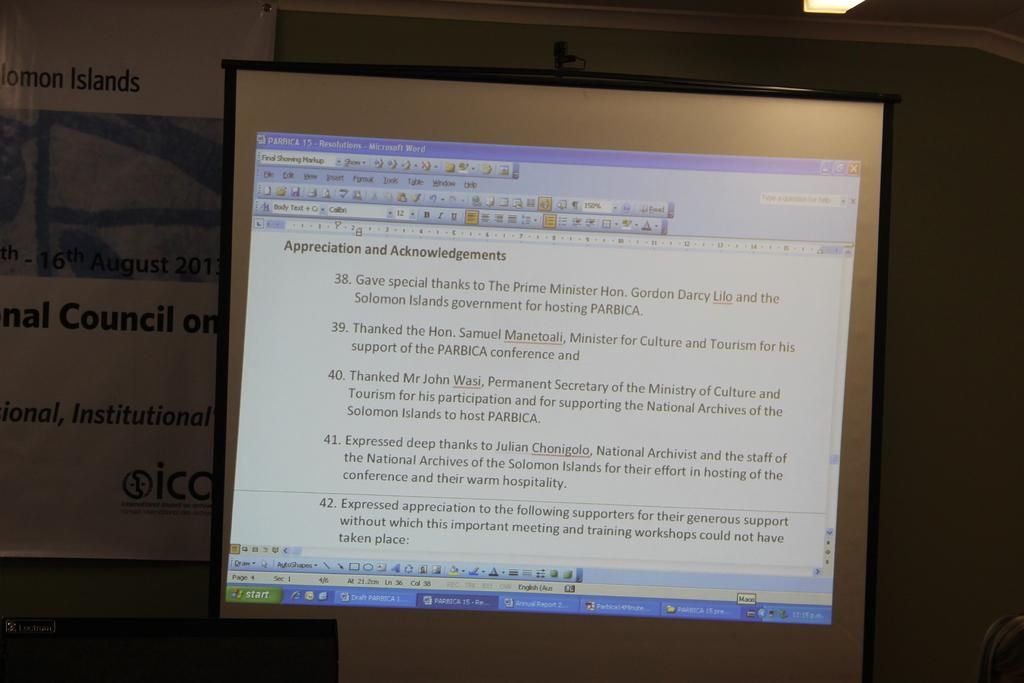Provide a one-sentence caption for the provided image. COmputer monitor which talks about the Appreciation and Acknowledgements. 